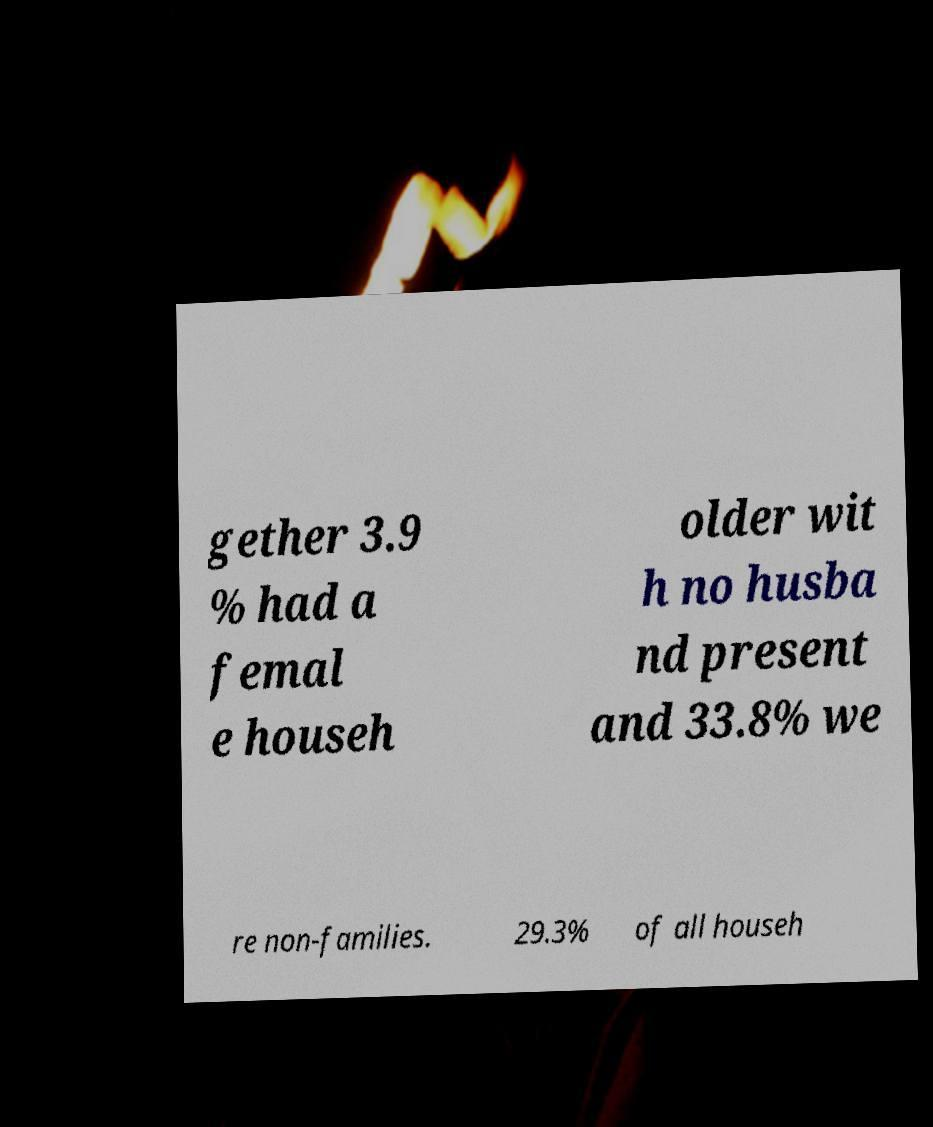Could you assist in decoding the text presented in this image and type it out clearly? gether 3.9 % had a femal e househ older wit h no husba nd present and 33.8% we re non-families. 29.3% of all househ 